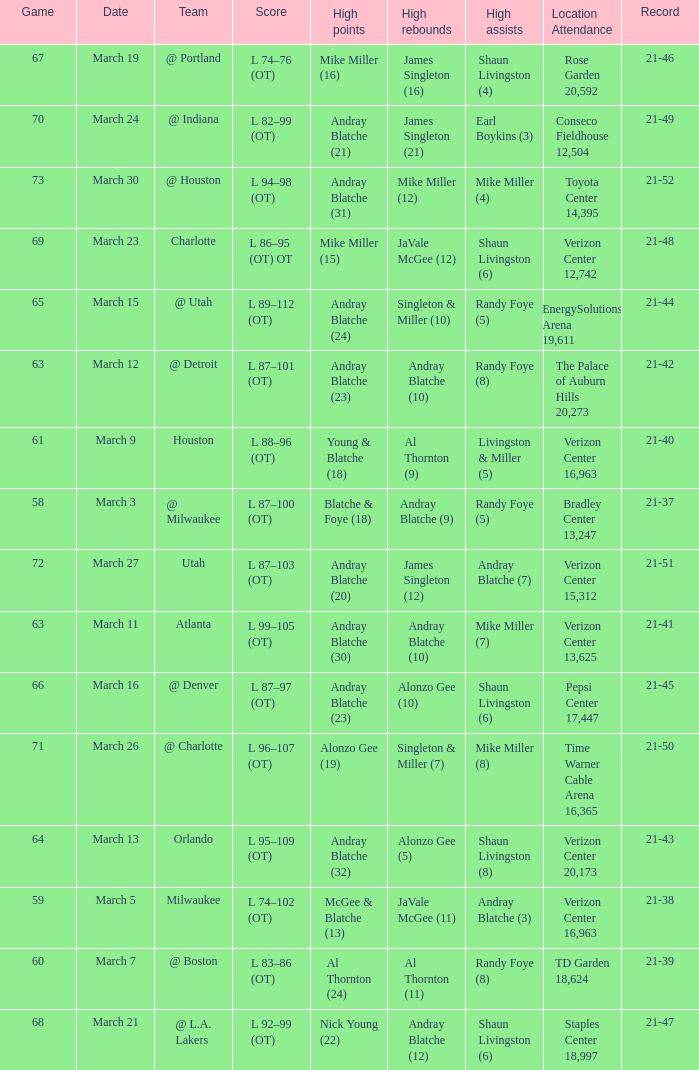On what date was the attendance at TD Garden 18,624? March 7. 